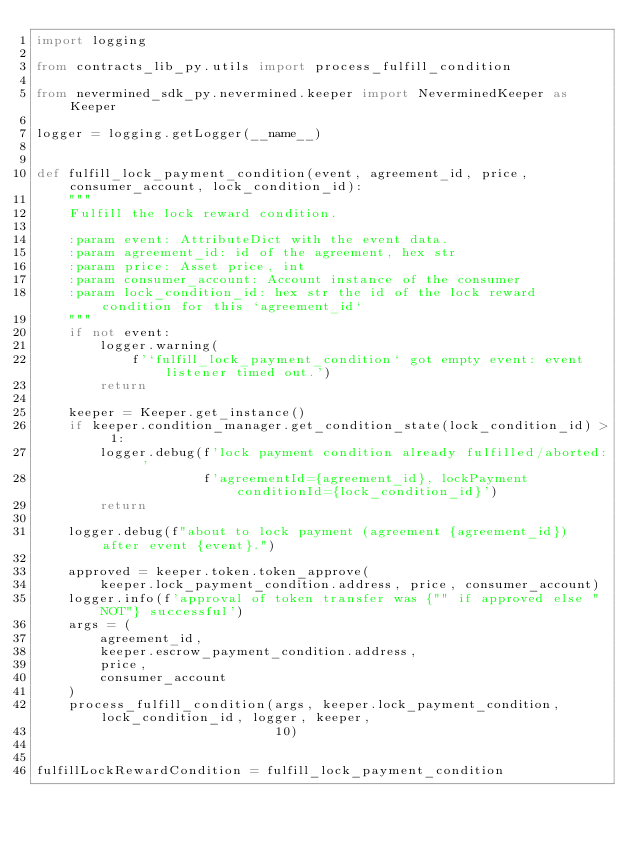Convert code to text. <code><loc_0><loc_0><loc_500><loc_500><_Python_>import logging

from contracts_lib_py.utils import process_fulfill_condition

from nevermined_sdk_py.nevermined.keeper import NeverminedKeeper as Keeper

logger = logging.getLogger(__name__)


def fulfill_lock_payment_condition(event, agreement_id, price, consumer_account, lock_condition_id):
    """
    Fulfill the lock reward condition.

    :param event: AttributeDict with the event data.
    :param agreement_id: id of the agreement, hex str
    :param price: Asset price, int
    :param consumer_account: Account instance of the consumer
    :param lock_condition_id: hex str the id of the lock reward condition for this `agreement_id`
    """
    if not event:
        logger.warning(
            f'`fulfill_lock_payment_condition` got empty event: event listener timed out.')
        return

    keeper = Keeper.get_instance()
    if keeper.condition_manager.get_condition_state(lock_condition_id) > 1:
        logger.debug(f'lock payment condition already fulfilled/aborted: '
                     f'agreementId={agreement_id}, lockPayment conditionId={lock_condition_id}')
        return

    logger.debug(f"about to lock payment (agreement {agreement_id}) after event {event}.")

    approved = keeper.token.token_approve(
        keeper.lock_payment_condition.address, price, consumer_account)
    logger.info(f'approval of token transfer was {"" if approved else "NOT"} successful')
    args = (
        agreement_id,
        keeper.escrow_payment_condition.address,
        price,
        consumer_account
    )
    process_fulfill_condition(args, keeper.lock_payment_condition, lock_condition_id, logger, keeper,
                              10)


fulfillLockRewardCondition = fulfill_lock_payment_condition
</code> 